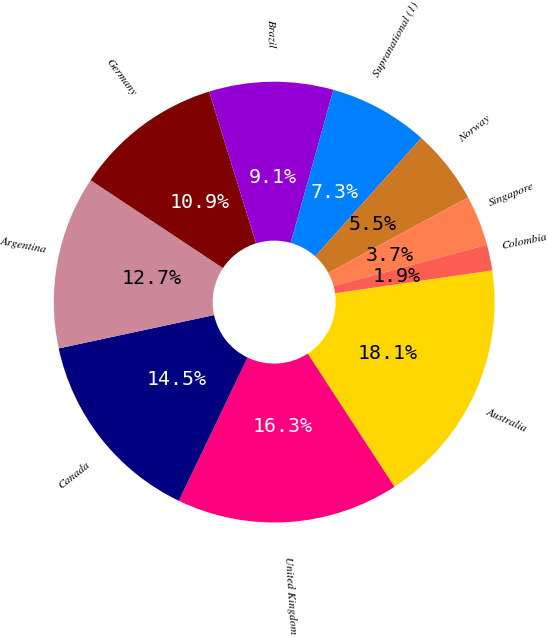<chart> <loc_0><loc_0><loc_500><loc_500><pie_chart><fcel>Australia<fcel>United Kingdom<fcel>Canada<fcel>Argentina<fcel>Germany<fcel>Brazil<fcel>Supranational (1)<fcel>Norway<fcel>Singapore<fcel>Colombia<nl><fcel>18.11%<fcel>16.31%<fcel>14.51%<fcel>12.7%<fcel>10.9%<fcel>9.1%<fcel>7.3%<fcel>5.49%<fcel>3.69%<fcel>1.89%<nl></chart> 